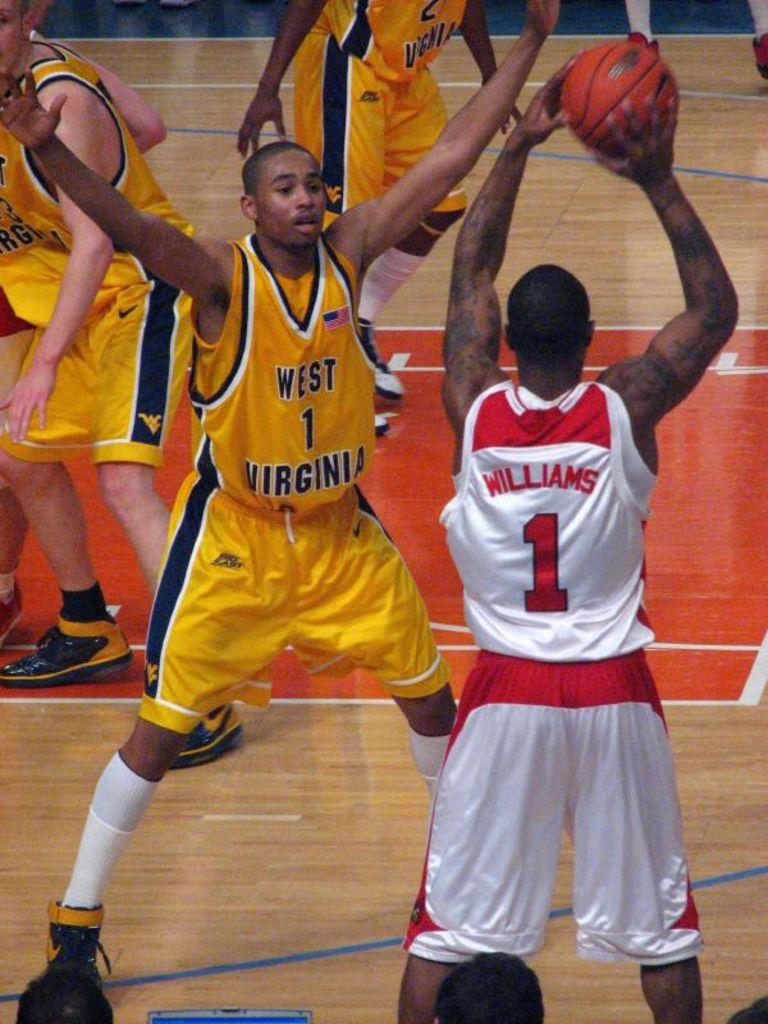<image>
Summarize the visual content of the image. A basketball player in yellow with west virginia on his short tries to stop his opponent in white throwing the ball. 